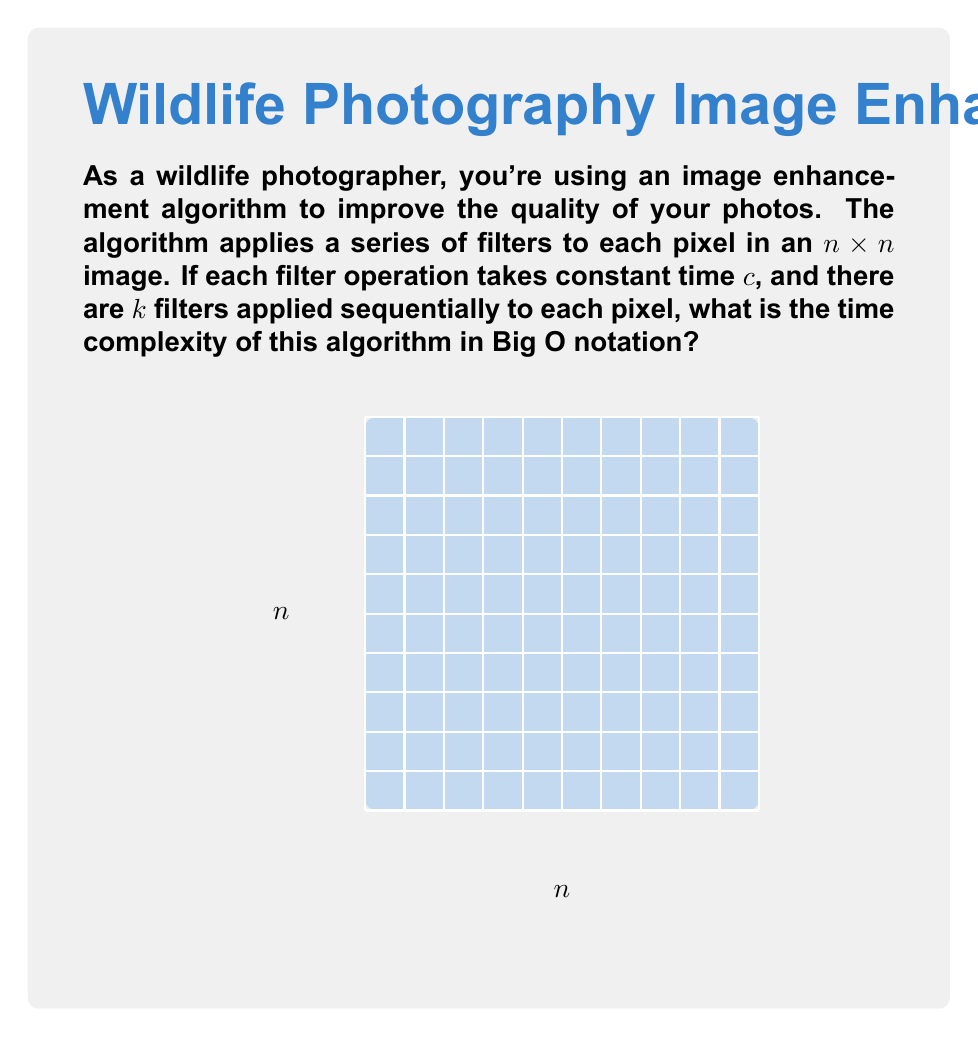Solve this math problem. Let's break this down step by step:

1) First, we need to consider how many operations are performed on each pixel:
   - Each pixel undergoes $k$ filter operations
   - Each filter operation takes constant time $c$
   - So, the time for each pixel is $O(k)$ (since $c$ is constant)

2) Now, we need to consider how many pixels are in the image:
   - The image is $n \times n$
   - So, there are $n^2$ pixels in total

3) For each of the $n^2$ pixels, we perform $O(k)$ operations:
   - Total operations = $n^2 \times O(k)$ = $O(kn^2)$

4) In Big O notation, we typically don't include constant factors unless they're exponential. Since $k$ is a constant (the number of filters doesn't change with the size of the image), we can simplify this to:
   
   $O(kn^2)$ = $O(n^2)$

This means the time complexity grows quadratically with the size of the image, which is typical for algorithms that process every pixel in an image.
Answer: $O(n^2)$ 